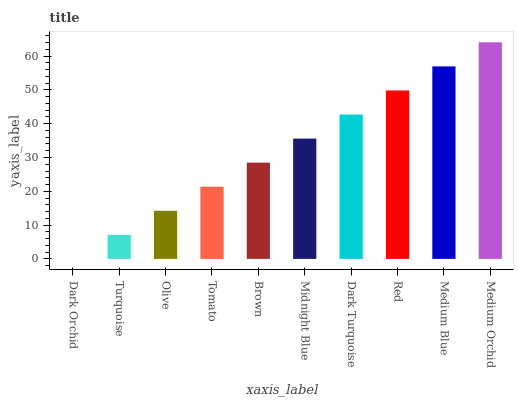Is Dark Orchid the minimum?
Answer yes or no. Yes. Is Medium Orchid the maximum?
Answer yes or no. Yes. Is Turquoise the minimum?
Answer yes or no. No. Is Turquoise the maximum?
Answer yes or no. No. Is Turquoise greater than Dark Orchid?
Answer yes or no. Yes. Is Dark Orchid less than Turquoise?
Answer yes or no. Yes. Is Dark Orchid greater than Turquoise?
Answer yes or no. No. Is Turquoise less than Dark Orchid?
Answer yes or no. No. Is Midnight Blue the high median?
Answer yes or no. Yes. Is Brown the low median?
Answer yes or no. Yes. Is Red the high median?
Answer yes or no. No. Is Olive the low median?
Answer yes or no. No. 